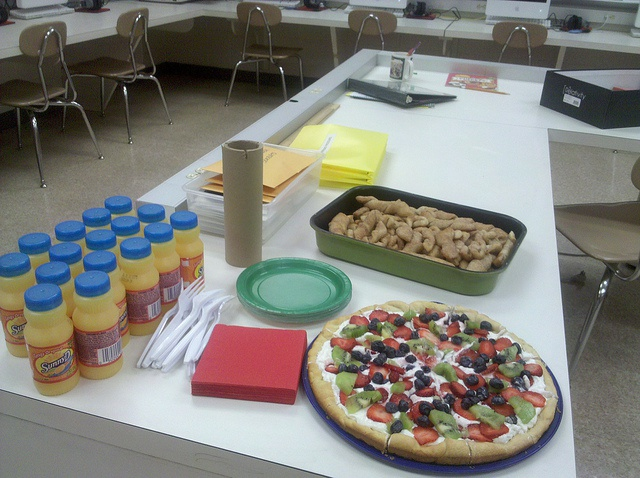Describe the objects in this image and their specific colors. I can see dining table in black, lightgray, darkgray, gray, and olive tones, pizza in black, tan, darkgray, brown, and gray tones, chair in black and gray tones, bottle in black, olive, gray, and blue tones, and bottle in black, olive, gray, and maroon tones in this image. 